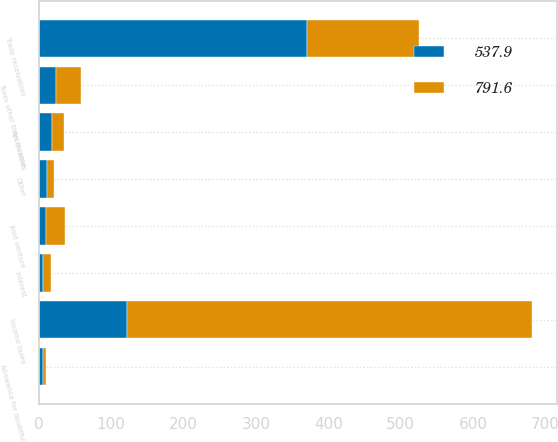<chart> <loc_0><loc_0><loc_500><loc_500><stacked_bar_chart><ecel><fcel>Receivables<fcel>Trade receivables<fcel>Income taxes<fcel>Taxes other than income<fcel>Joint venture<fcel>Interest<fcel>Other<fcel>Allowance for doubtful<nl><fcel>537.9<fcel>17.6<fcel>370.7<fcel>122.2<fcel>23.9<fcel>10.5<fcel>5.5<fcel>11.3<fcel>6.2<nl><fcel>791.6<fcel>17.6<fcel>154.9<fcel>560.2<fcel>34.9<fcel>25.3<fcel>10.9<fcel>9.2<fcel>3.8<nl></chart> 